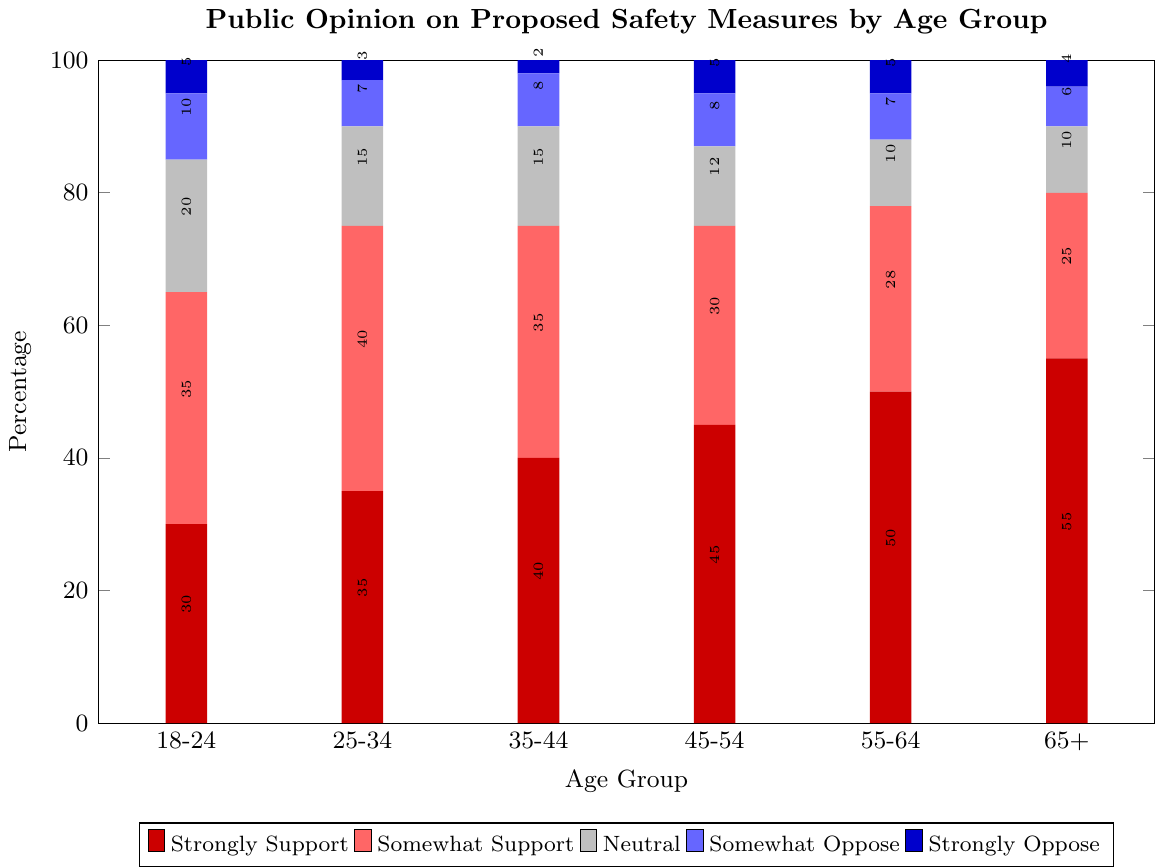What age group shows the highest percentage of strong support for the proposed safety measures? Look at the bar segment for "Strongly Support" and compare the heights across all age groups. The highest bar segment for "Strongly Support" is in the 65+ age group.
Answer: 65+ Which age group has the lowest percentage of strong opposition to the safety measures? Compare the segment heights for "Strongly Oppose" across all age groups. The age group 35-44 has the shortest bar segment for "Strongly Oppose".
Answer: 35-44 What is the total percentage of support (both strongly and somewhat) for the 25-34 age group? Add the percentage values for "Strongly Support" and "Somewhat Support" for the 25-34 age group. The values are 35% and 40%, giving a total of 35 + 40 = 75%.
Answer: 75% How do the strongly opposed opinions differ between the 18-24 and 45-54 age groups? Subtract the percentage of "Strongly Oppose" in the 18-24 age group from that in the 45-54 age group. The values are 5% (18-24) and 5% (45-54), giving a difference of 5 - 5 = 0%.
Answer: 0% Which age group has the highest percentage of neutral opinions? Compare the heights of the "Neutral" segments across all age groups. The 18-24 age group has the highest "Neutral" segment at 20%.
Answer: 18-24 Among the age groups 45-54 and 55-64, which one shows higher combined opposition (somewhat and strongly)? Add the "Somewhat Oppose" and "Strongly Oppose" values for both age groups. For 45-54: 8 + 5 = 13%. For 55-64: 7 + 5 = 12%. Thus, 45-54 has a higher combined opposition.
Answer: 45-54 Is the neutral opinion percentage greater in the 35-44 age group than in the 55-64 age group? Compare the "Neutral" bar segments for the two age groups. Both age groups have the same neutral opinion percentage of 15%.
Answer: No What is the total percentage for the 65+ age group for positions other than support (i.e., neutral, somewhat oppose, strongly oppose)? Add the percentages for "Neutral", "Somewhat Oppose", and "Strongly Oppose" for the 65+ age group. The values are 10% (Neutral), 6% (Somewhat Oppose), and 4% (Strongly Oppose). The total is 10 + 6 + 4 = 20%.
Answer: 20% Which age group shows the least variation in opinions, and what does that mean in the context of the graph? Calculate the difference between the highest and lowest percentages in each age group. The age group 35-44 shows the least variation with percentages ranging from 2% to 40% (a variation of 38%). This indicates more evenly distributed opinions within this age group.
Answer: 35-44 Compare the total percentages of opposition (somewhat and strongly) between the 18-24 and 65+ age groups. Which group has higher opposition? Add "Somewhat Oppose" and "Strongly Oppose" values for both age groups. For 18-24: 10 + 5 = 15%. For 65+: 6 + 4 = 10%. Thus, the 18-24 age group has higher opposition.
Answer: 18-24 